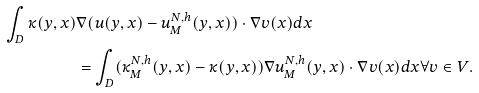<formula> <loc_0><loc_0><loc_500><loc_500>\int _ { D } \kappa ( y , x ) & \nabla ( u ( y , x ) - u _ { M } ^ { N , h } ( y , x ) ) \cdot \nabla v ( x ) d x \\ & = \int _ { D } ( \kappa _ { M } ^ { N , h } ( y , x ) - \kappa ( y , x ) ) \nabla u _ { M } ^ { N , h } ( y , x ) \cdot \nabla v ( x ) d x \forall v \in V .</formula> 